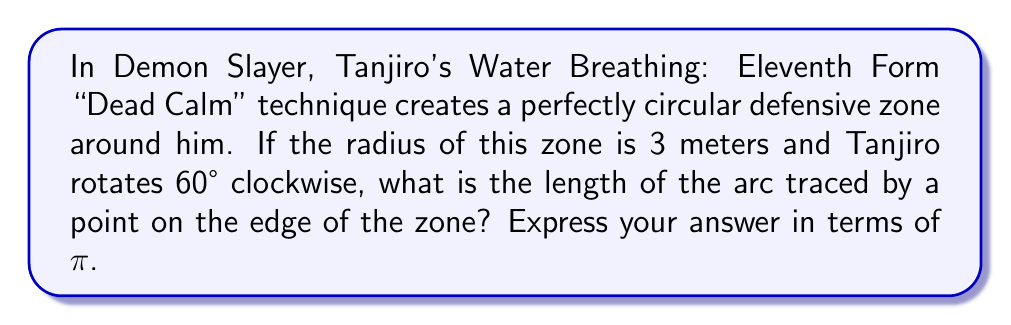Show me your answer to this math problem. Let's approach this step-by-step, using our knowledge of circular geometry and trigonometry:

1) First, recall the formula for arc length:
   $$ s = r\theta $$
   where $s$ is the arc length, $r$ is the radius, and $\theta$ is the angle in radians.

2) We're given the radius ($r = 3$ meters) and the angle in degrees (60°), but we need to convert the angle to radians:
   $$ \theta = 60° \cdot \frac{\pi}{180°} = \frac{\pi}{3} \text{ radians} $$

3) Now we can substitute these values into our arc length formula:
   $$ s = r\theta = 3 \cdot \frac{\pi}{3} = \pi \text{ meters} $$

This result shows the beautiful symmetry in Tanjiro's technique, as the arc length is exactly π meters, reflecting the circular nature of his Dead Calm form.
Answer: $\pi$ meters 